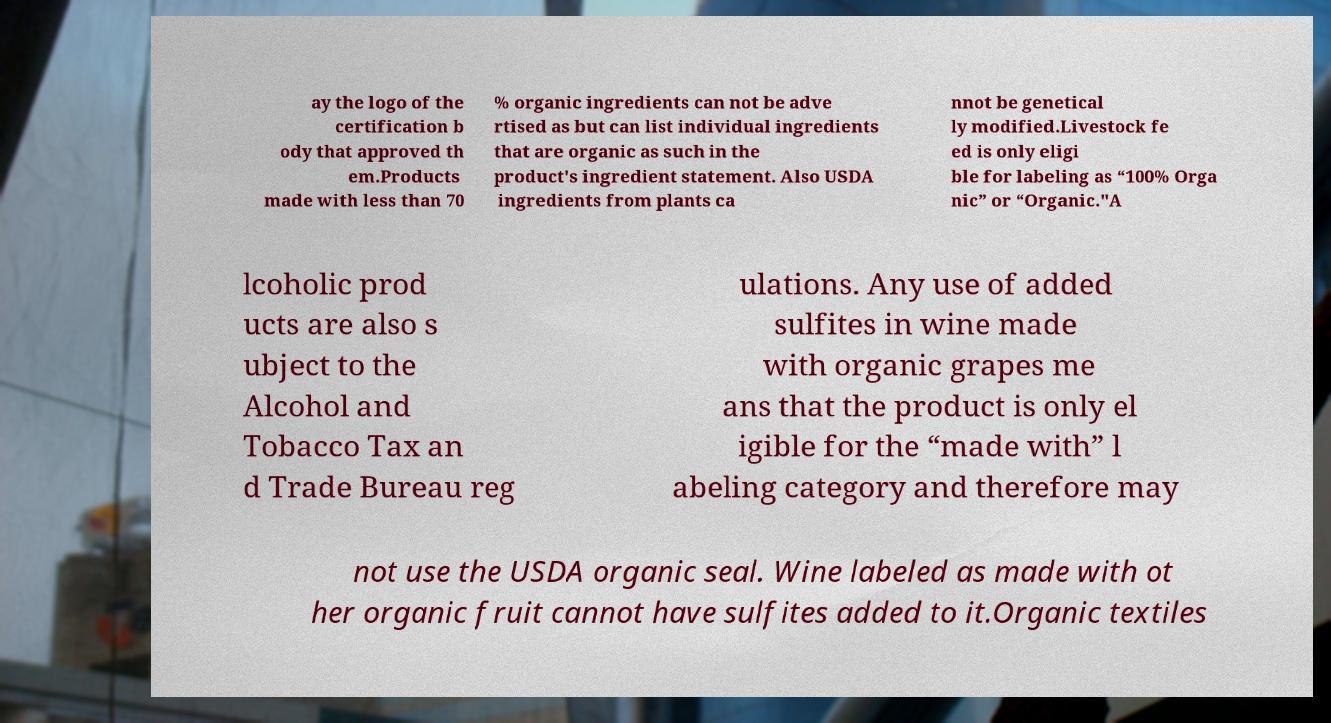What messages or text are displayed in this image? I need them in a readable, typed format. ay the logo of the certification b ody that approved th em.Products made with less than 70 % organic ingredients can not be adve rtised as but can list individual ingredients that are organic as such in the product's ingredient statement. Also USDA ingredients from plants ca nnot be genetical ly modified.Livestock fe ed is only eligi ble for labeling as “100% Orga nic” or “Organic."A lcoholic prod ucts are also s ubject to the Alcohol and Tobacco Tax an d Trade Bureau reg ulations. Any use of added sulfites in wine made with organic grapes me ans that the product is only el igible for the “made with” l abeling category and therefore may not use the USDA organic seal. Wine labeled as made with ot her organic fruit cannot have sulfites added to it.Organic textiles 